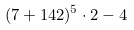<formula> <loc_0><loc_0><loc_500><loc_500>( 7 + 1 4 2 ) ^ { 5 } \cdot 2 - 4</formula> 